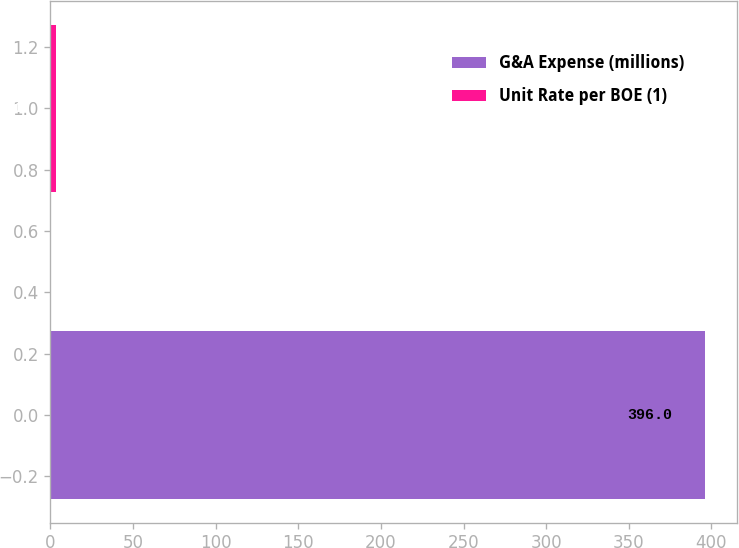Convert chart. <chart><loc_0><loc_0><loc_500><loc_500><bar_chart><fcel>G&A Expense (millions)<fcel>Unit Rate per BOE (1)<nl><fcel>396<fcel>3.11<nl></chart> 